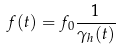Convert formula to latex. <formula><loc_0><loc_0><loc_500><loc_500>f ( t ) = f _ { 0 } \frac { 1 } { \gamma _ { h } ( t ) }</formula> 